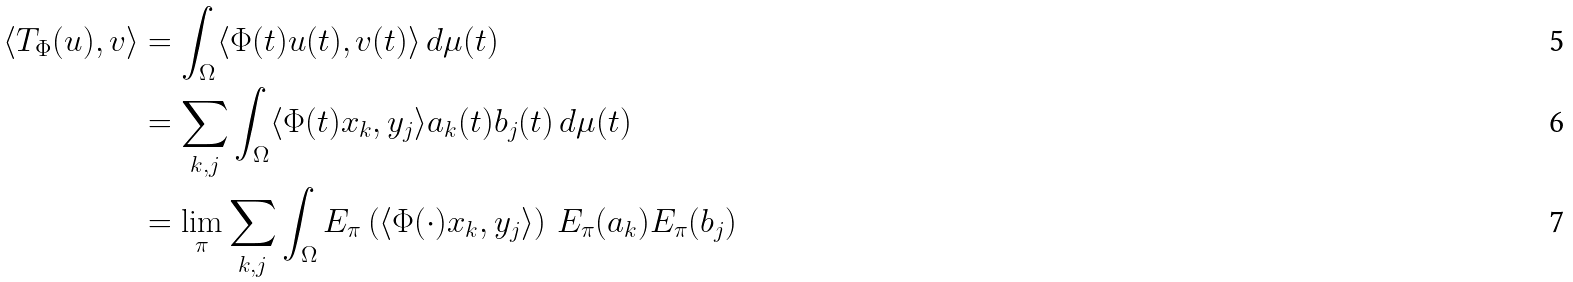Convert formula to latex. <formula><loc_0><loc_0><loc_500><loc_500>\langle T _ { \Phi } ( u ) , v \rangle & = \int _ { \Omega } \langle \Phi ( t ) u ( t ) , v ( t ) \rangle \, d \mu ( t ) \\ & = \sum _ { k , j } \int _ { \Omega } \langle \Phi ( t ) x _ { k } , y _ { j } \rangle a _ { k } ( t ) b _ { j } ( t ) \, d \mu ( t ) \\ & = \lim _ { \pi } \sum _ { k , j } \int _ { \Omega } E _ { \pi } \left ( \langle \Phi ( \cdot ) x _ { k } , y _ { j } \rangle \right ) \, E _ { \pi } ( a _ { k } ) E _ { \pi } ( b _ { j } )</formula> 